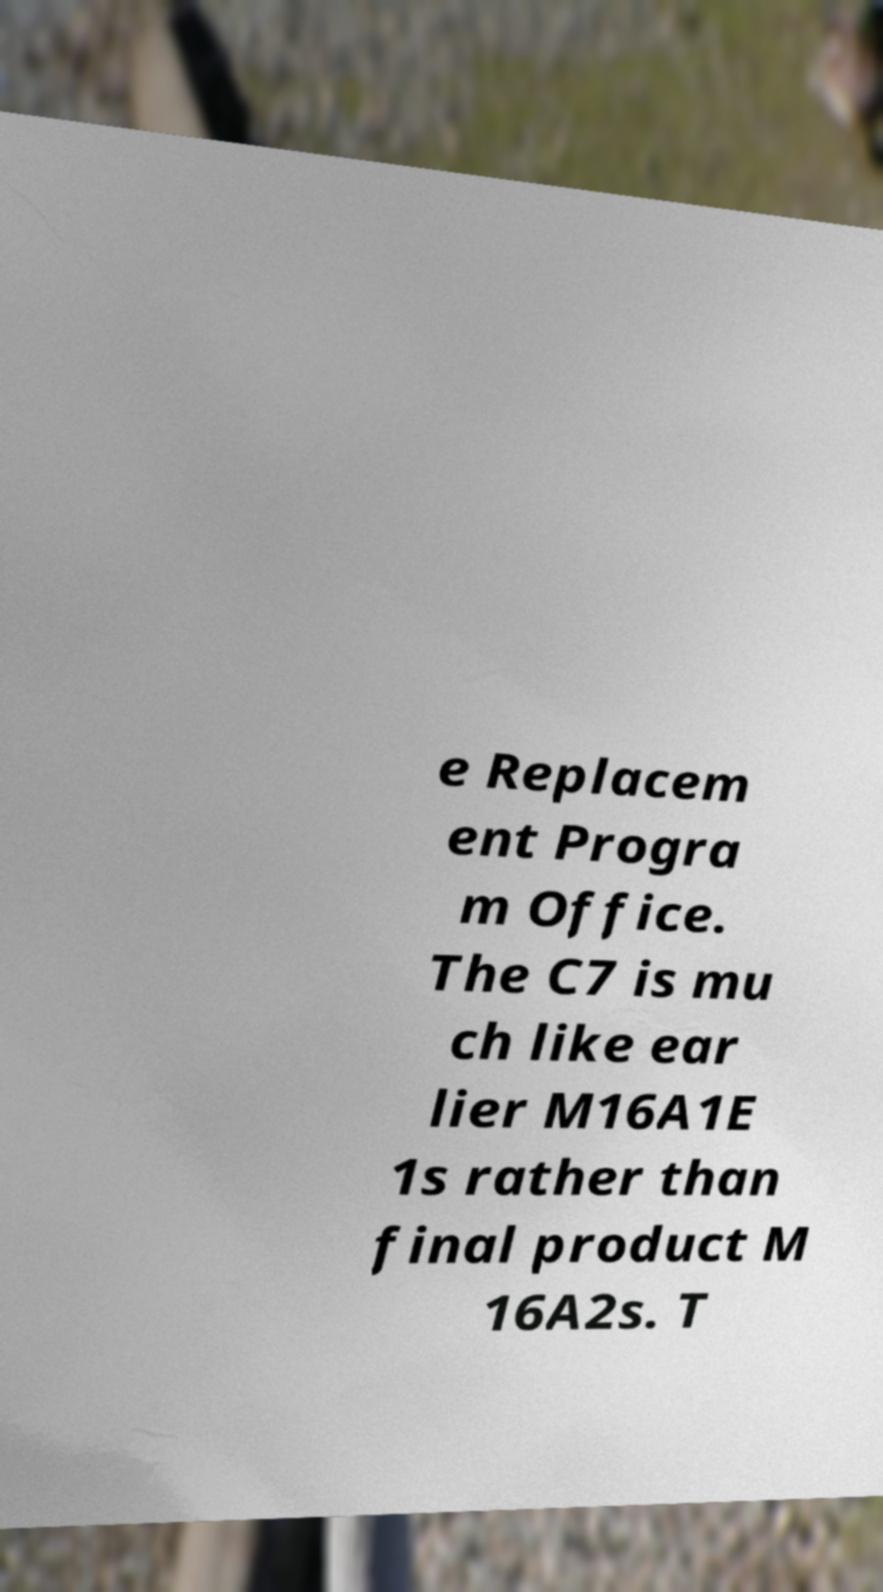Please read and relay the text visible in this image. What does it say? e Replacem ent Progra m Office. The C7 is mu ch like ear lier M16A1E 1s rather than final product M 16A2s. T 